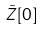Convert formula to latex. <formula><loc_0><loc_0><loc_500><loc_500>\tilde { Z } [ 0 ]</formula> 